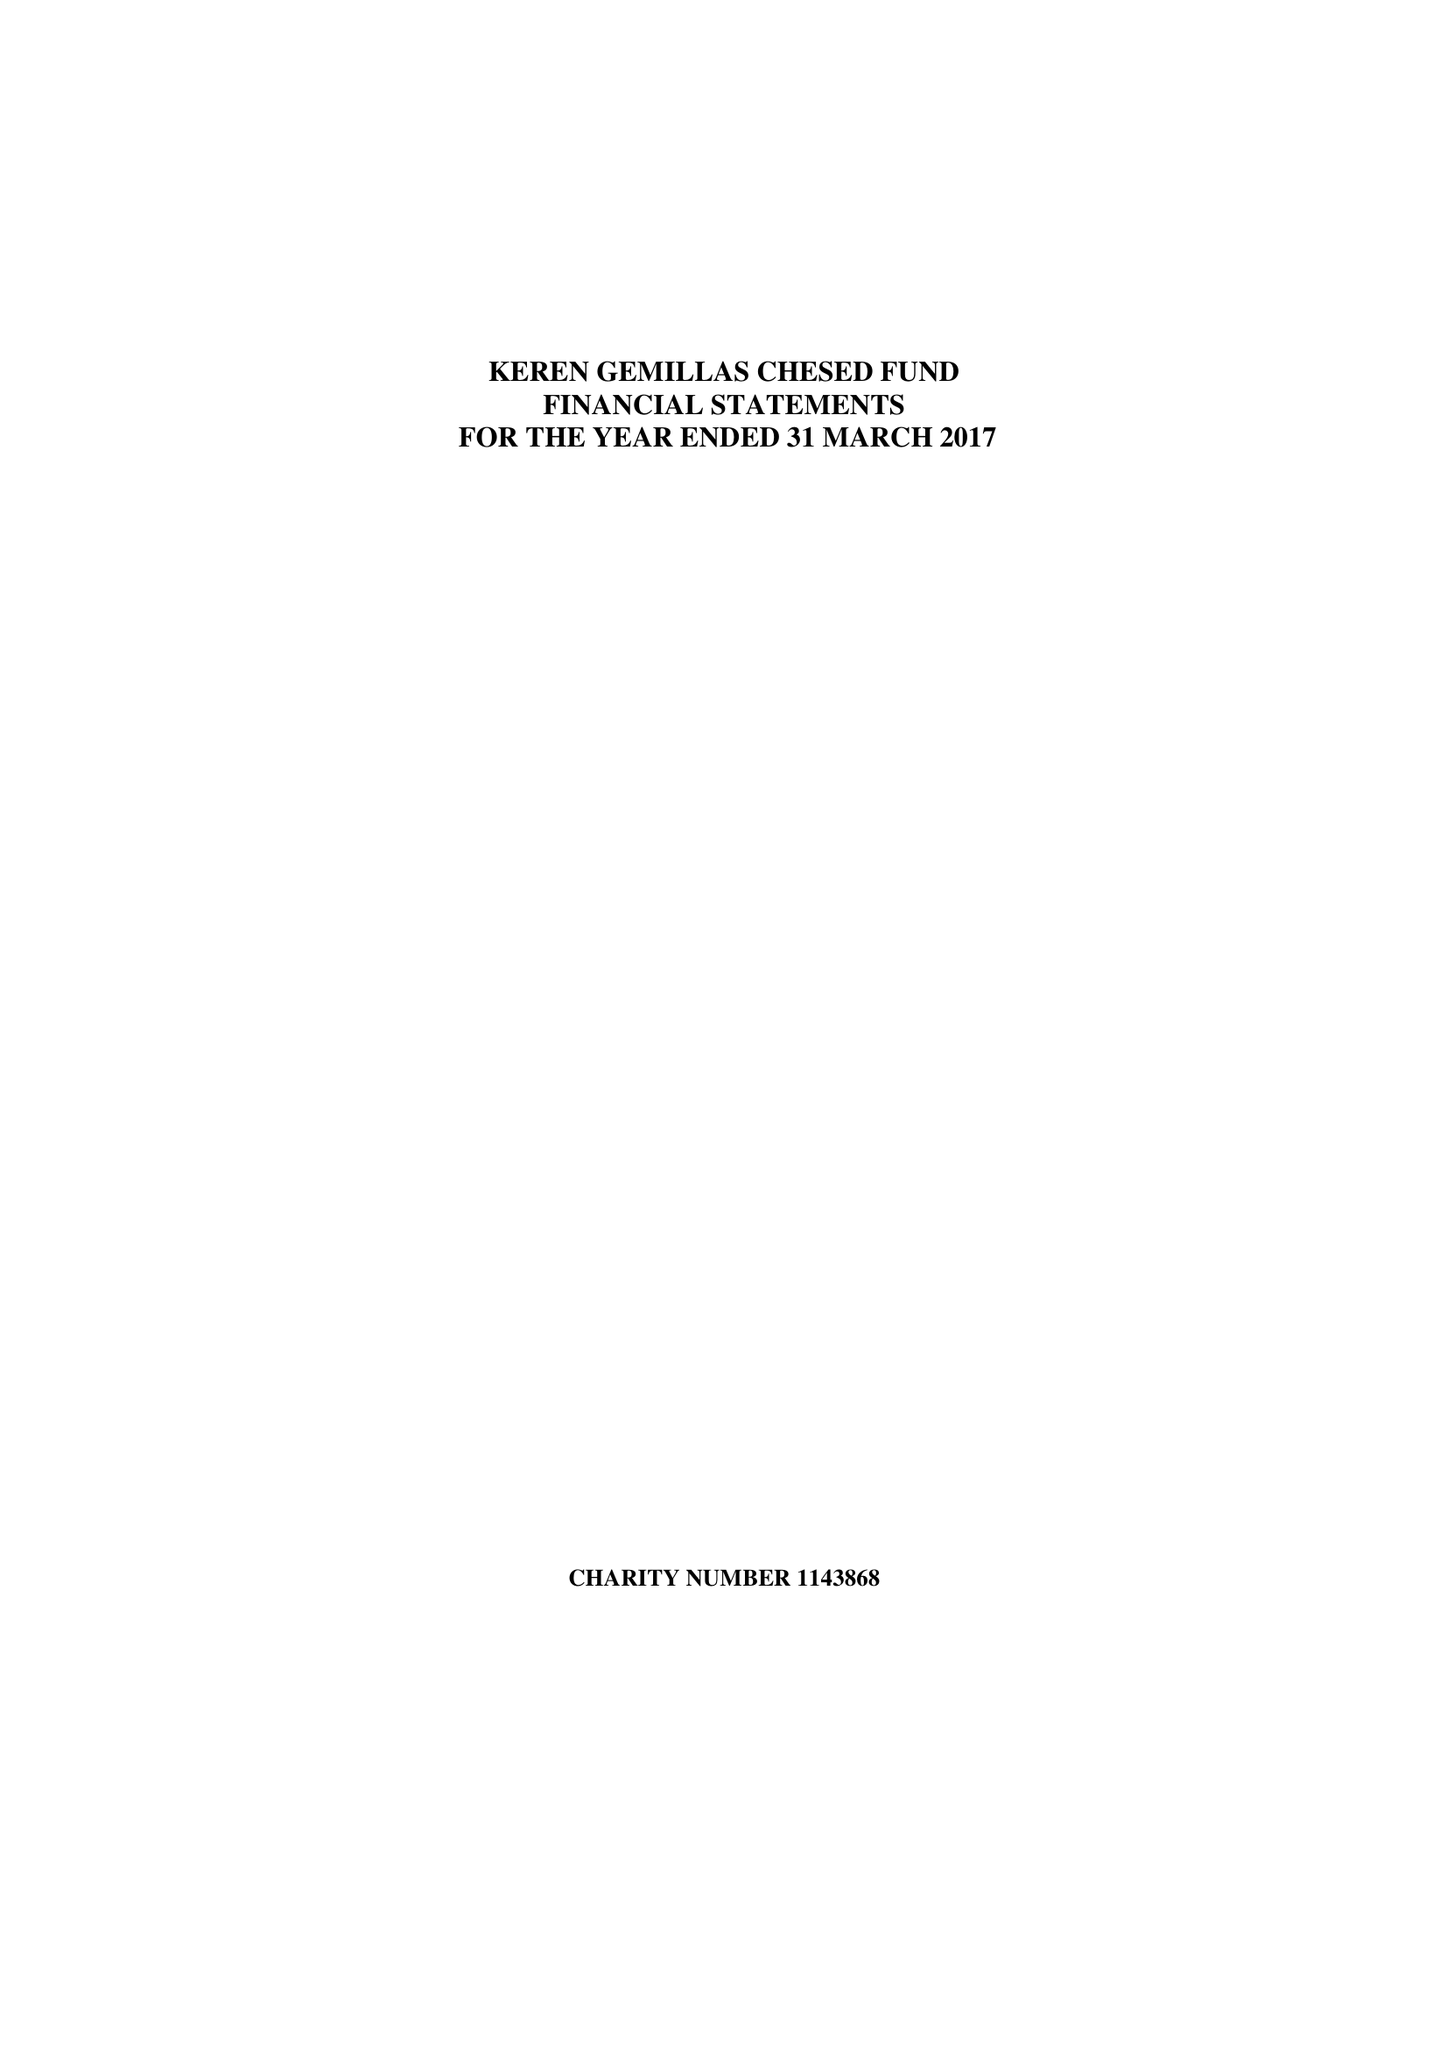What is the value for the address__street_line?
Answer the question using a single word or phrase. None 